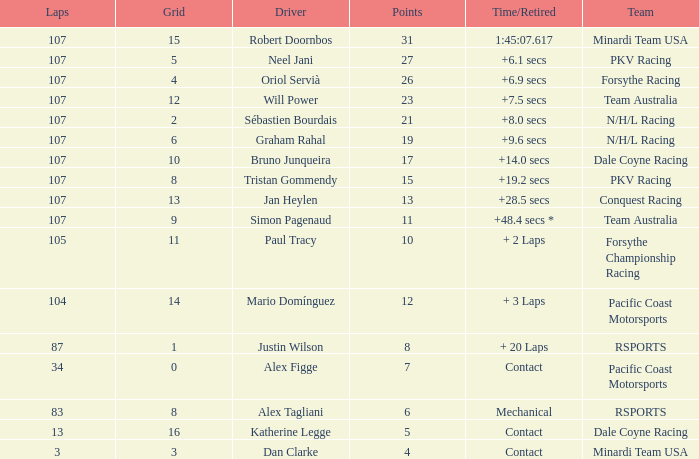What is mario domínguez's average Grid? 14.0. 